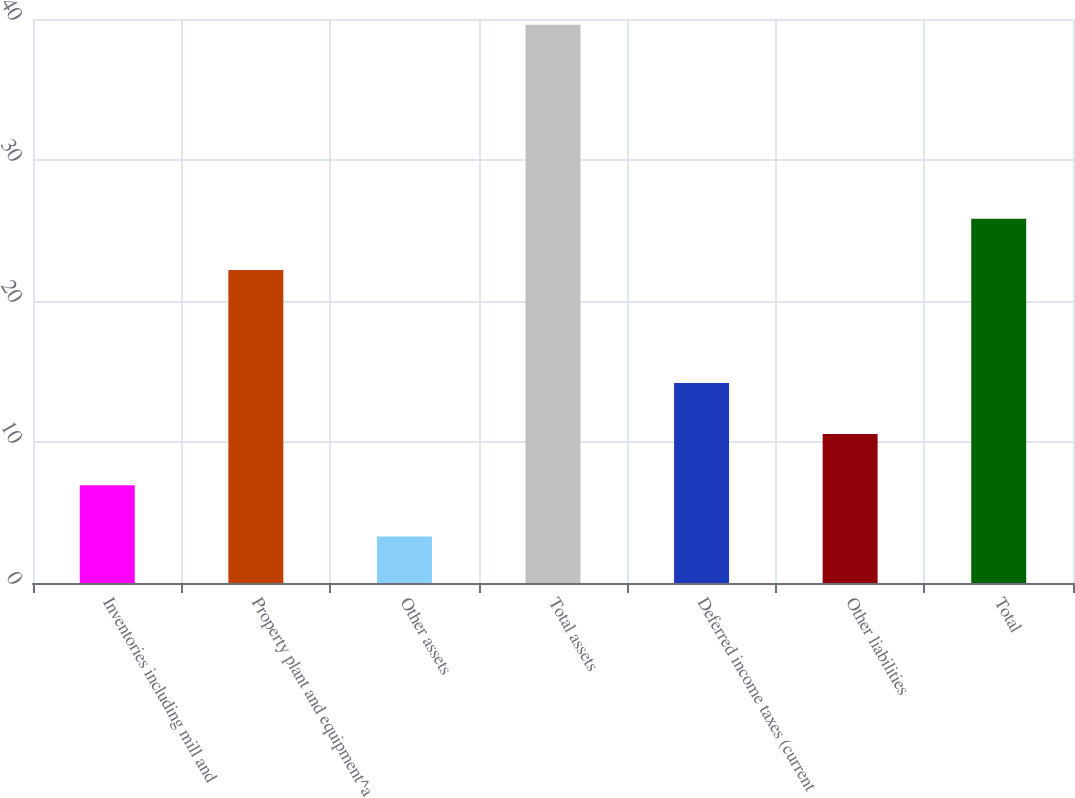<chart> <loc_0><loc_0><loc_500><loc_500><bar_chart><fcel>Inventories including mill and<fcel>Property plant and equipment^a<fcel>Other assets<fcel>Total assets<fcel>Deferred income taxes (current<fcel>Other liabilities<fcel>Total<nl><fcel>6.93<fcel>22.2<fcel>3.3<fcel>39.6<fcel>14.19<fcel>10.56<fcel>25.83<nl></chart> 